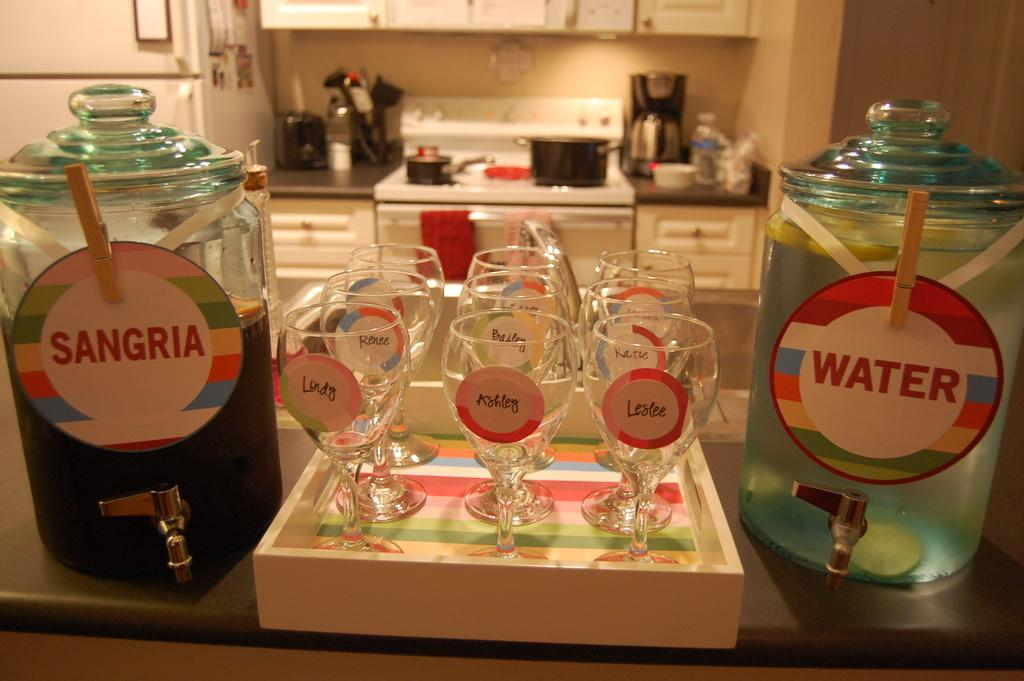<image>
Write a terse but informative summary of the picture. a few pitchers of Sangria and water and glasses with girls names on them. 